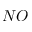Convert formula to latex. <formula><loc_0><loc_0><loc_500><loc_500>N O</formula> 